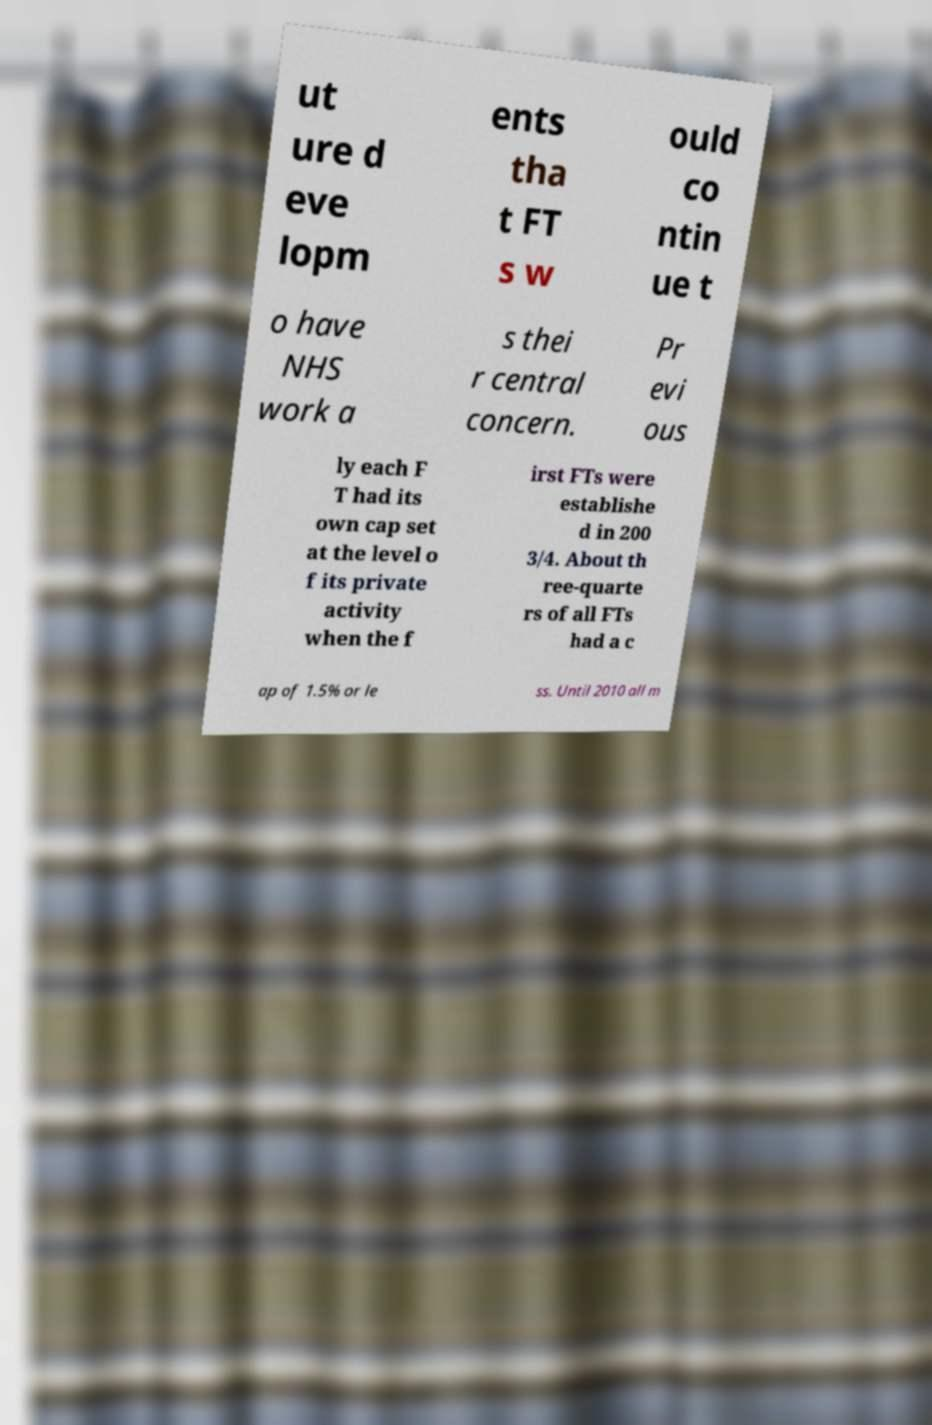Could you extract and type out the text from this image? ut ure d eve lopm ents tha t FT s w ould co ntin ue t o have NHS work a s thei r central concern. Pr evi ous ly each F T had its own cap set at the level o f its private activity when the f irst FTs were establishe d in 200 3/4. About th ree-quarte rs of all FTs had a c ap of 1.5% or le ss. Until 2010 all m 